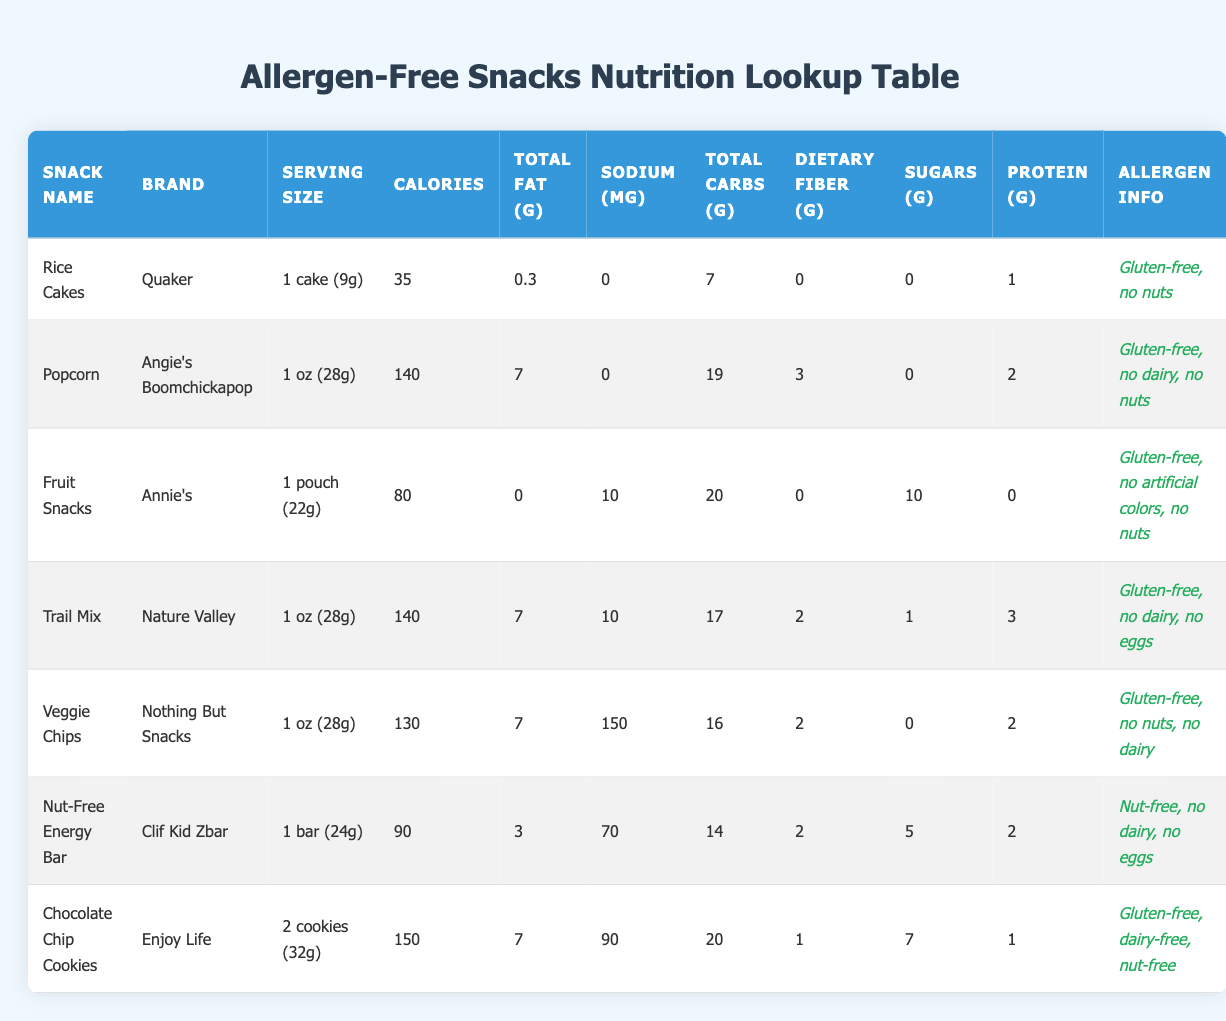What is the serving size of the Rice Cakes? The serving size for Rice Cakes is displayed in the "Serving Size" column. It states "1 cake (9g)."
Answer: 1 cake (9g) Which snack has the highest protein content? By checking the "Protein (g)" column, Nut-Free Energy Bar, Trail Mix, and Popcorn all contain different values. The Nut-Free Energy Bar has 2g, Trail Mix has 3g, and Popcorn contains 2g. Thus, Trail Mix has the highest protein content at 3g.
Answer: Trail Mix True or False: Veggie Chips contain nuts. To answer this, we can look at the "Allergen Info" section for Veggie Chips. It states "Gluten-free, no nuts, no dairy," indicating that it does not contain nuts.
Answer: False What is the total amount of carbohydrates in all snacks? We will sum the values from the "Total Carbohydrates (g)" column: Rice Cakes (7) + Popcorn (19) + Fruit Snacks (20) + Trail Mix (17) + Veggie Chips (16) + Nut-Free Energy Bar (14) + Chocolate Chip Cookies (20) = 113g of total carbohydrates.
Answer: 113g Which snack is labeled as dairy-free? We can examine the "Allergen Info" column to find any mentioned dairy-free snacks. The Chocolate Chip Cookies, Popcorn, and Nut-Free Energy Bar are noted as dairy-free. The Chocolate Chip Cookies specifically state "dairy-free, nut-free."
Answer: Chocolate Chip Cookies 